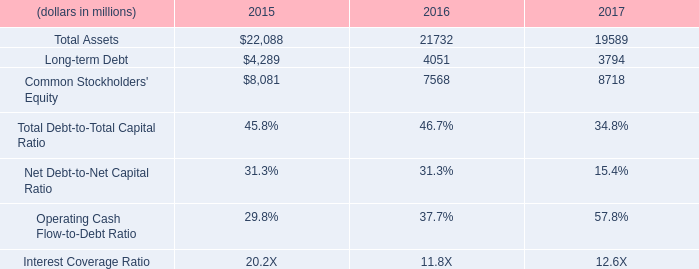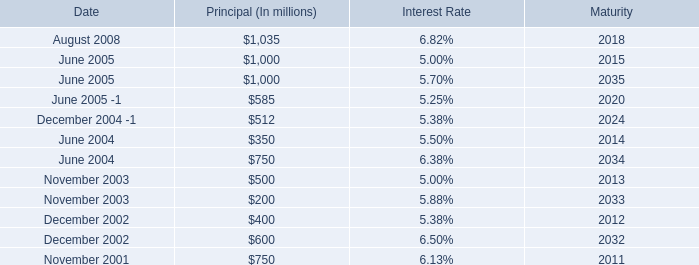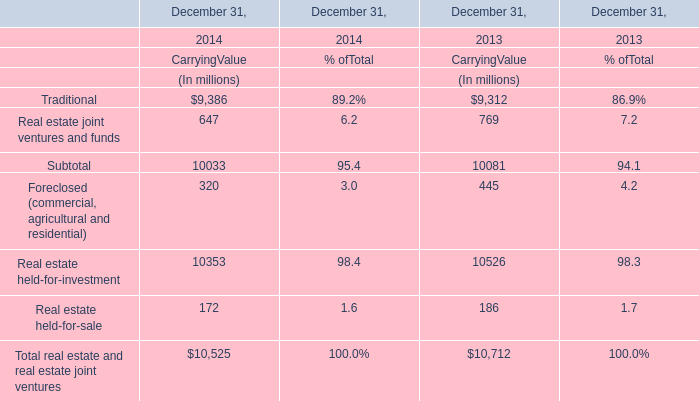If Real estate held-for-investment at Carrying Value on December 31 develops with the same growth rate in 2014, what will it reach in 2015? (in million) 
Computations: (10353 * (1 + ((10353 - 10526) / 10526)))
Answer: 10182.84334. 